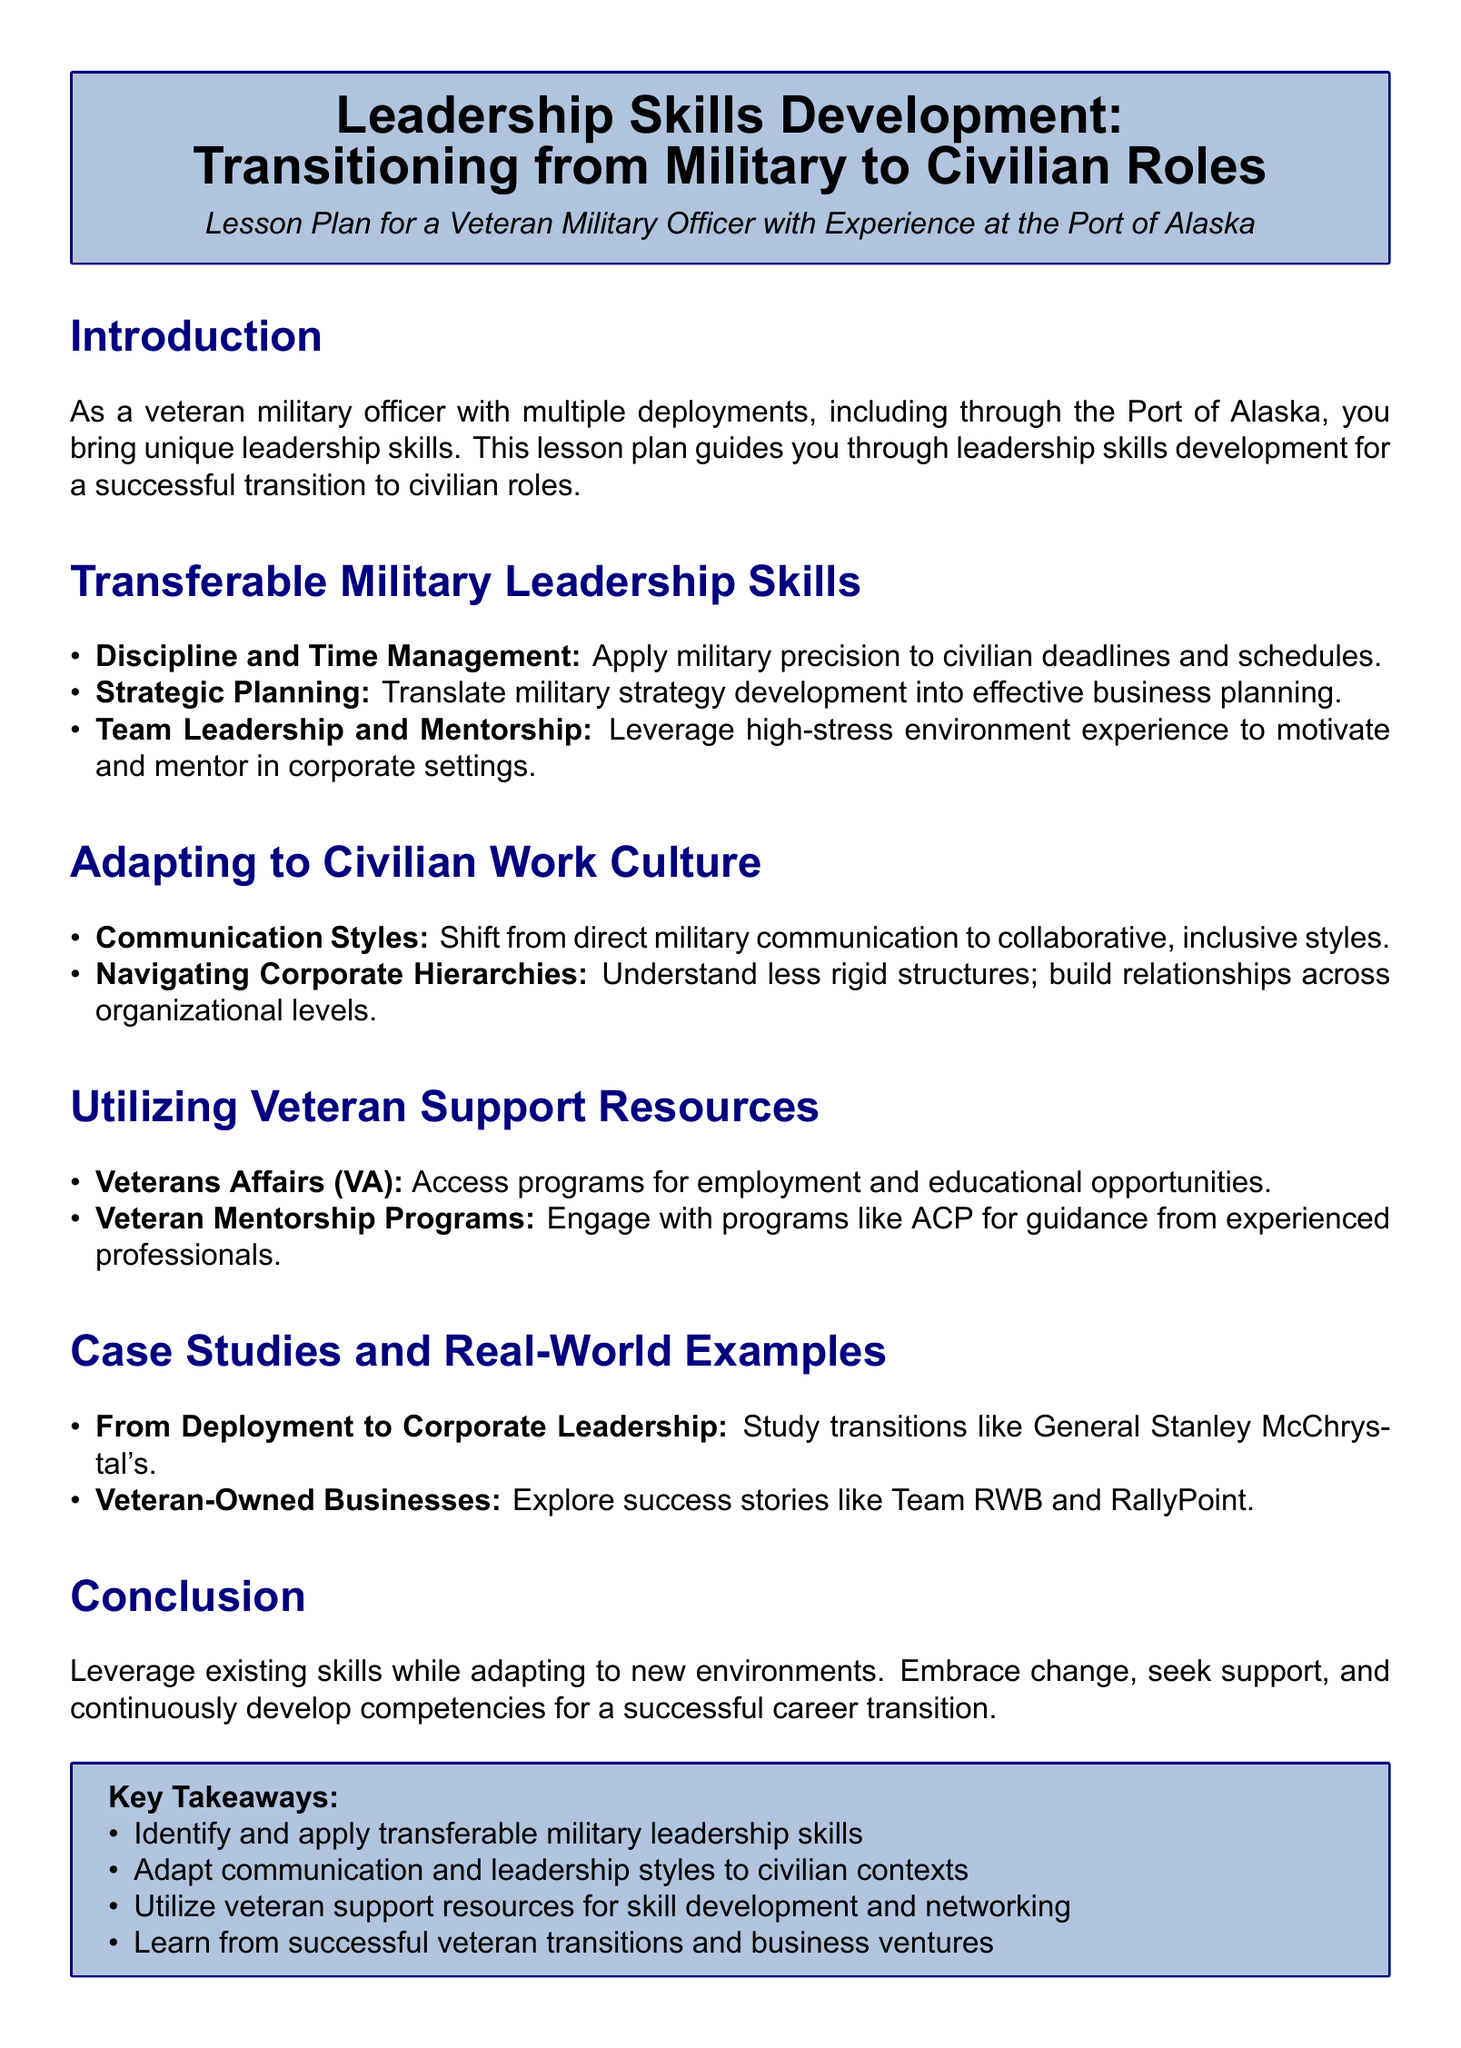what is the title of the lesson plan? The title outlines the focus of the course, which is about developing leadership skills for veterans transitioning to civilian roles.
Answer: Leadership Skills Development: Transitioning from Military to Civilian Roles what unique experience does the lesson plan target? The lesson plan is specifically designed for individuals with military backgrounds, considering their unique experiences during transitions.
Answer: Veteran Military Officer with Experience at the Port of Alaska name a transferable skill highlighted in the document. The document lists specific military skills that can be applied to civilian roles, emphasizing their importance in the transition.
Answer: Strategic Planning what is one way to adapt to civilian work culture? The document suggests particular strategies to modify behavior and interaction in a civilian context, reflecting a common need for adjustment.
Answer: Communication Styles which organization is mentioned for accessing employment programs? The lesson plan references specific organizations that provide resources to veterans, aiding in their transition to civilian careers.
Answer: Veterans Affairs (VA) who is a case study example of a successful transition? The document names notable individuals or organizations that have successfully transitioned from military service to civilian roles, providing inspiration.
Answer: General Stanley McChrystal how many key takeaways are listed at the end? The conclusion section summarizes core lessons from the document, making it easier for readers to grasp essential points for their transition.
Answer: Four 